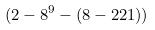Convert formula to latex. <formula><loc_0><loc_0><loc_500><loc_500>( 2 - 8 ^ { 9 } - ( 8 - 2 2 1 ) )</formula> 